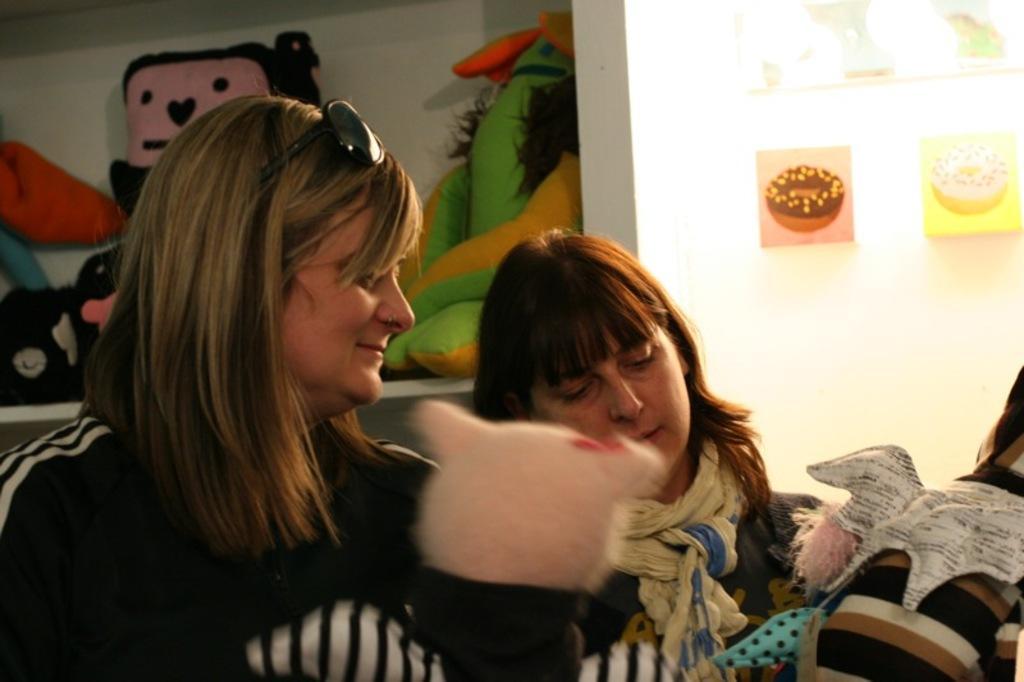Could you give a brief overview of what you see in this image? The woman in black jacket and the woman in blue jacket are holding stuffed toys in their hands. Behind them, we see stuffed toys placed on the wall shelf. Beside that, we see a white wall on which posters are pasted. 